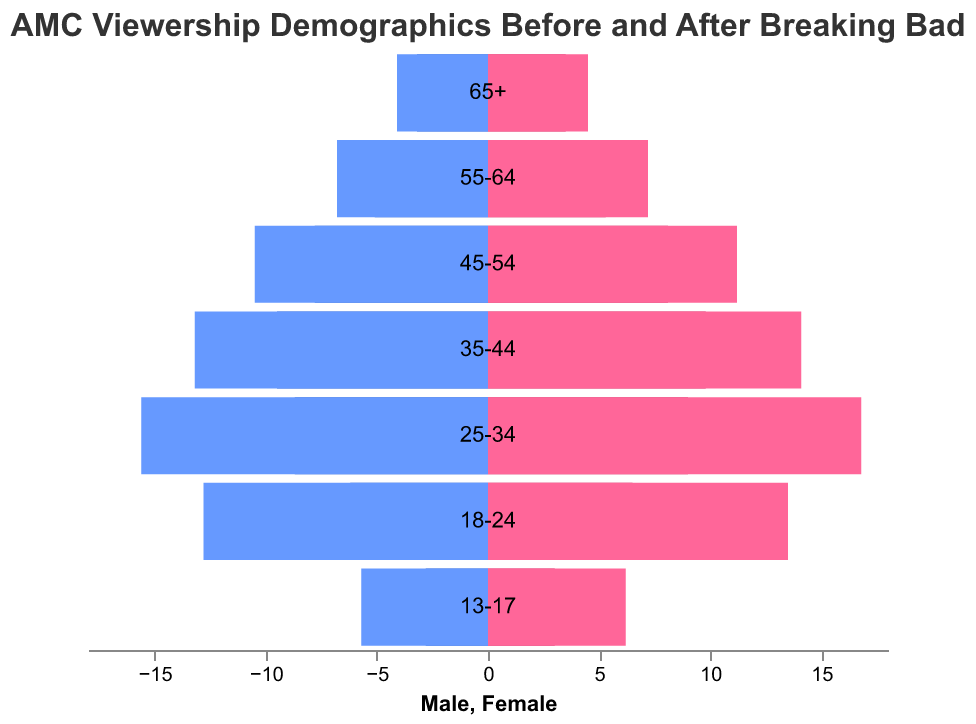What's the general title of the figure? The title of the figure is usually located at the top and provides an overview of what the chart represents. From the description, the title is "AMC Viewership Demographics Before and After Breaking Bad."
Answer: AMC Viewership Demographics Before and After Breaking Bad Which age group had the highest percentage increase in male viewership after Breaking Bad? To find the highest percentage increase, look at each age group and compare the "Male After" column to the "Male Before" column. The 25-34 age group increased from 8.7 to 15.6, which is the most significant change.
Answer: 25-34 What is the total increase in female viewership for the 18-24 age group? To get the total increase, subtract the "Female Before" from the "Female After" for the 18-24 age group. So, it's 13.5 - 6.5.
Answer: 7 Which gender had a larger viewership increase in the 45-54 age group? Compare the increase in male viewership (10.5 - 7.8) to the increase in female viewership (11.2 - 8.1) for the 45-54 age group.
Answer: Female What is the visual difference between the bars representing male and female viewership before and after Breaking Bad? The bars are differentiated by color: shades of blue represent male viewership (darker blue for before, lighter blue for after), while shades of pink or red represent female viewership (darker pink for before, lighter pink for after).
Answer: Colors How has the viewership of the 13-17 age group changed for both males and females? Look at the values for "Male Before" (2.8), "Female Before" (3.0), "Male After" (5.7), and "Female After" (6.2) for the 13-17 age group. Both males and females roughly doubled their viewership.
Answer: Both doubled What is the overall trend in viewership for older age groups (55+) after the release of Breaking Bad? Compare the values for the 55-64 and 65+ age groups. Both males and females have increased viewership, with older age groups showing a noticeable but smaller increase compared to younger groups.
Answer: Increased In which age group is the female viewership highest after Breaking Bad? Look at the "Female After" column and find the age group with the highest value. The 25-34 age group has the highest female viewership after Breaking Bad with a value of 16.8.
Answer: 25-34 How does the viewership of the 35-44 age group for males compare before and after Breaking Bad? Compare the "Male Before" value of 9.5 to the "Male After" value of 13.2 for the 35-44 age group.
Answer: Increased What noticeable pattern can you see in the demographics of viewership before and after Breaking Bad overall? Generally, all age groups for both genders show an increase in viewership after Breaking Bad, with a more significant rise seen in younger age groups (18-34) compared to older age groups.
Answer: Overall increase 